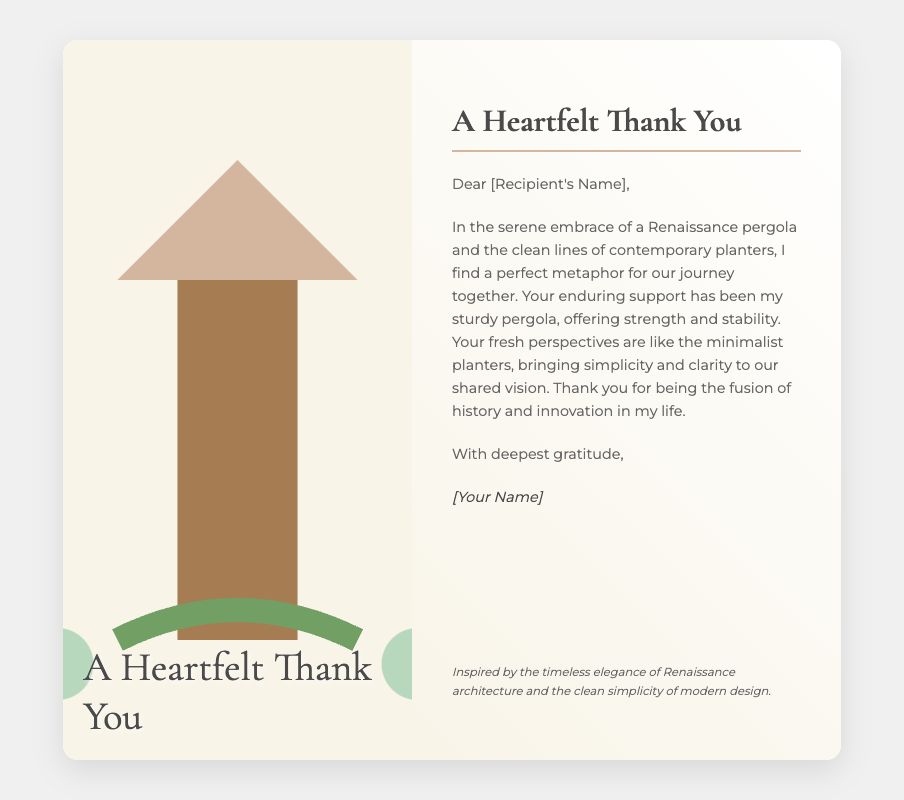What is the title of the card? The title of the card can be found at the bottom of the card front and is "A Heartfelt Thank You".
Answer: A Heartfelt Thank You Who is the card addressed to? The card includes a placeholder for the recipient's name, indicated by [Recipient's Name].
Answer: [Recipient's Name] What elements inspire the designer's journey? The designer draws inspiration from a Renaissance pergola and contemporary planters, which are mentioned in the message.
Answer: Renaissance pergola and contemporary planters What is the tone of the message in the card? The message conveys gratitude and appreciation to the recipient for their support and fresh perspectives.
Answer: Gratitude and appreciation What design styles are fused in the card's illustration? The illustration features a combination of Renaissance-style and minimalist design elements, as stated in the card.
Answer: Renaissance-style and minimalist Who signs the card? The card includes a placeholder for the sender's name, indicated by [Your Name].
Answer: [Your Name] What is the dominant color scheme of the card? The card has a color scheme that includes warm tones, particularly beige and green, as can be inferred from the background and other elements.
Answer: Beige and green What is the footnote's primary theme? The footnote provides insight into the inspirations behind the design, focusing on Renaissance architecture and modern design.
Answer: Timeless elegance of Renaissance architecture and clean simplicity of modern design 